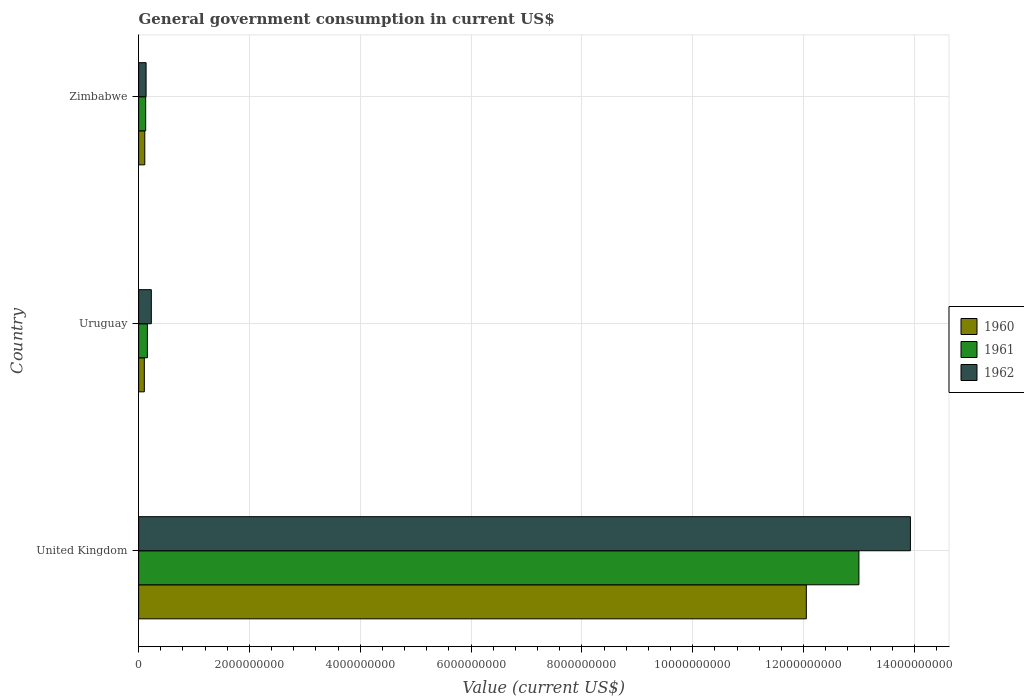How many groups of bars are there?
Offer a terse response. 3. In how many cases, is the number of bars for a given country not equal to the number of legend labels?
Your answer should be compact. 0. What is the government conusmption in 1961 in United Kingdom?
Provide a succinct answer. 1.30e+1. Across all countries, what is the maximum government conusmption in 1961?
Provide a succinct answer. 1.30e+1. Across all countries, what is the minimum government conusmption in 1961?
Your answer should be very brief. 1.27e+08. In which country was the government conusmption in 1962 maximum?
Offer a very short reply. United Kingdom. In which country was the government conusmption in 1962 minimum?
Give a very brief answer. Zimbabwe. What is the total government conusmption in 1960 in the graph?
Make the answer very short. 1.23e+1. What is the difference between the government conusmption in 1962 in United Kingdom and that in Uruguay?
Give a very brief answer. 1.37e+1. What is the difference between the government conusmption in 1960 in Zimbabwe and the government conusmption in 1962 in Uruguay?
Offer a very short reply. -1.18e+08. What is the average government conusmption in 1962 per country?
Make the answer very short. 4.76e+09. What is the difference between the government conusmption in 1962 and government conusmption in 1961 in Zimbabwe?
Ensure brevity in your answer.  7.39e+06. In how many countries, is the government conusmption in 1960 greater than 10400000000 US$?
Make the answer very short. 1. What is the ratio of the government conusmption in 1961 in United Kingdom to that in Zimbabwe?
Offer a very short reply. 102.08. What is the difference between the highest and the second highest government conusmption in 1962?
Provide a short and direct response. 1.37e+1. What is the difference between the highest and the lowest government conusmption in 1962?
Provide a succinct answer. 1.38e+1. How many bars are there?
Provide a short and direct response. 9. Where does the legend appear in the graph?
Give a very brief answer. Center right. How many legend labels are there?
Keep it short and to the point. 3. How are the legend labels stacked?
Ensure brevity in your answer.  Vertical. What is the title of the graph?
Your answer should be very brief. General government consumption in current US$. What is the label or title of the X-axis?
Give a very brief answer. Value (current US$). What is the Value (current US$) in 1960 in United Kingdom?
Your response must be concise. 1.20e+1. What is the Value (current US$) in 1961 in United Kingdom?
Keep it short and to the point. 1.30e+1. What is the Value (current US$) of 1962 in United Kingdom?
Ensure brevity in your answer.  1.39e+1. What is the Value (current US$) in 1960 in Uruguay?
Provide a short and direct response. 1.03e+08. What is the Value (current US$) of 1961 in Uruguay?
Your response must be concise. 1.58e+08. What is the Value (current US$) in 1962 in Uruguay?
Offer a very short reply. 2.29e+08. What is the Value (current US$) in 1960 in Zimbabwe?
Your answer should be compact. 1.11e+08. What is the Value (current US$) of 1961 in Zimbabwe?
Provide a succinct answer. 1.27e+08. What is the Value (current US$) in 1962 in Zimbabwe?
Offer a very short reply. 1.35e+08. Across all countries, what is the maximum Value (current US$) of 1960?
Your answer should be compact. 1.20e+1. Across all countries, what is the maximum Value (current US$) in 1961?
Ensure brevity in your answer.  1.30e+1. Across all countries, what is the maximum Value (current US$) in 1962?
Your response must be concise. 1.39e+1. Across all countries, what is the minimum Value (current US$) in 1960?
Ensure brevity in your answer.  1.03e+08. Across all countries, what is the minimum Value (current US$) of 1961?
Offer a very short reply. 1.27e+08. Across all countries, what is the minimum Value (current US$) of 1962?
Give a very brief answer. 1.35e+08. What is the total Value (current US$) of 1960 in the graph?
Provide a succinct answer. 1.23e+1. What is the total Value (current US$) in 1961 in the graph?
Ensure brevity in your answer.  1.33e+1. What is the total Value (current US$) of 1962 in the graph?
Offer a terse response. 1.43e+1. What is the difference between the Value (current US$) in 1960 in United Kingdom and that in Uruguay?
Offer a very short reply. 1.19e+1. What is the difference between the Value (current US$) in 1961 in United Kingdom and that in Uruguay?
Keep it short and to the point. 1.28e+1. What is the difference between the Value (current US$) in 1962 in United Kingdom and that in Uruguay?
Give a very brief answer. 1.37e+1. What is the difference between the Value (current US$) of 1960 in United Kingdom and that in Zimbabwe?
Keep it short and to the point. 1.19e+1. What is the difference between the Value (current US$) of 1961 in United Kingdom and that in Zimbabwe?
Offer a terse response. 1.29e+1. What is the difference between the Value (current US$) in 1962 in United Kingdom and that in Zimbabwe?
Offer a very short reply. 1.38e+1. What is the difference between the Value (current US$) of 1960 in Uruguay and that in Zimbabwe?
Your response must be concise. -8.26e+06. What is the difference between the Value (current US$) in 1961 in Uruguay and that in Zimbabwe?
Provide a succinct answer. 3.09e+07. What is the difference between the Value (current US$) in 1962 in Uruguay and that in Zimbabwe?
Keep it short and to the point. 9.44e+07. What is the difference between the Value (current US$) in 1960 in United Kingdom and the Value (current US$) in 1961 in Uruguay?
Offer a very short reply. 1.19e+1. What is the difference between the Value (current US$) of 1960 in United Kingdom and the Value (current US$) of 1962 in Uruguay?
Provide a short and direct response. 1.18e+1. What is the difference between the Value (current US$) in 1961 in United Kingdom and the Value (current US$) in 1962 in Uruguay?
Your answer should be very brief. 1.28e+1. What is the difference between the Value (current US$) in 1960 in United Kingdom and the Value (current US$) in 1961 in Zimbabwe?
Keep it short and to the point. 1.19e+1. What is the difference between the Value (current US$) of 1960 in United Kingdom and the Value (current US$) of 1962 in Zimbabwe?
Provide a short and direct response. 1.19e+1. What is the difference between the Value (current US$) of 1961 in United Kingdom and the Value (current US$) of 1962 in Zimbabwe?
Provide a succinct answer. 1.29e+1. What is the difference between the Value (current US$) of 1960 in Uruguay and the Value (current US$) of 1961 in Zimbabwe?
Your answer should be compact. -2.45e+07. What is the difference between the Value (current US$) in 1960 in Uruguay and the Value (current US$) in 1962 in Zimbabwe?
Ensure brevity in your answer.  -3.19e+07. What is the difference between the Value (current US$) in 1961 in Uruguay and the Value (current US$) in 1962 in Zimbabwe?
Make the answer very short. 2.35e+07. What is the average Value (current US$) of 1960 per country?
Your answer should be compact. 4.09e+09. What is the average Value (current US$) of 1961 per country?
Your response must be concise. 4.43e+09. What is the average Value (current US$) in 1962 per country?
Provide a succinct answer. 4.76e+09. What is the difference between the Value (current US$) in 1960 and Value (current US$) in 1961 in United Kingdom?
Provide a short and direct response. -9.49e+08. What is the difference between the Value (current US$) in 1960 and Value (current US$) in 1962 in United Kingdom?
Provide a short and direct response. -1.88e+09. What is the difference between the Value (current US$) of 1961 and Value (current US$) of 1962 in United Kingdom?
Offer a terse response. -9.29e+08. What is the difference between the Value (current US$) in 1960 and Value (current US$) in 1961 in Uruguay?
Keep it short and to the point. -5.54e+07. What is the difference between the Value (current US$) of 1960 and Value (current US$) of 1962 in Uruguay?
Ensure brevity in your answer.  -1.26e+08. What is the difference between the Value (current US$) in 1961 and Value (current US$) in 1962 in Uruguay?
Your answer should be very brief. -7.09e+07. What is the difference between the Value (current US$) in 1960 and Value (current US$) in 1961 in Zimbabwe?
Keep it short and to the point. -1.63e+07. What is the difference between the Value (current US$) in 1960 and Value (current US$) in 1962 in Zimbabwe?
Your response must be concise. -2.37e+07. What is the difference between the Value (current US$) of 1961 and Value (current US$) of 1962 in Zimbabwe?
Provide a succinct answer. -7.39e+06. What is the ratio of the Value (current US$) in 1960 in United Kingdom to that in Uruguay?
Your answer should be compact. 117.2. What is the ratio of the Value (current US$) in 1961 in United Kingdom to that in Uruguay?
Offer a terse response. 82.14. What is the ratio of the Value (current US$) of 1962 in United Kingdom to that in Uruguay?
Provide a succinct answer. 60.77. What is the ratio of the Value (current US$) in 1960 in United Kingdom to that in Zimbabwe?
Make the answer very short. 108.49. What is the ratio of the Value (current US$) in 1961 in United Kingdom to that in Zimbabwe?
Keep it short and to the point. 102.08. What is the ratio of the Value (current US$) in 1962 in United Kingdom to that in Zimbabwe?
Provide a short and direct response. 103.37. What is the ratio of the Value (current US$) in 1960 in Uruguay to that in Zimbabwe?
Your response must be concise. 0.93. What is the ratio of the Value (current US$) in 1961 in Uruguay to that in Zimbabwe?
Offer a terse response. 1.24. What is the ratio of the Value (current US$) of 1962 in Uruguay to that in Zimbabwe?
Make the answer very short. 1.7. What is the difference between the highest and the second highest Value (current US$) of 1960?
Make the answer very short. 1.19e+1. What is the difference between the highest and the second highest Value (current US$) of 1961?
Keep it short and to the point. 1.28e+1. What is the difference between the highest and the second highest Value (current US$) of 1962?
Your answer should be very brief. 1.37e+1. What is the difference between the highest and the lowest Value (current US$) in 1960?
Offer a terse response. 1.19e+1. What is the difference between the highest and the lowest Value (current US$) in 1961?
Provide a succinct answer. 1.29e+1. What is the difference between the highest and the lowest Value (current US$) of 1962?
Your answer should be very brief. 1.38e+1. 